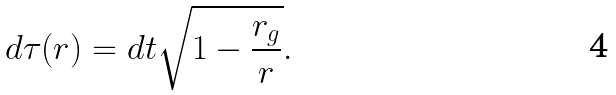Convert formula to latex. <formula><loc_0><loc_0><loc_500><loc_500>d \tau ( r ) = d t \sqrt { 1 - \frac { r _ { g } } { r } } .</formula> 